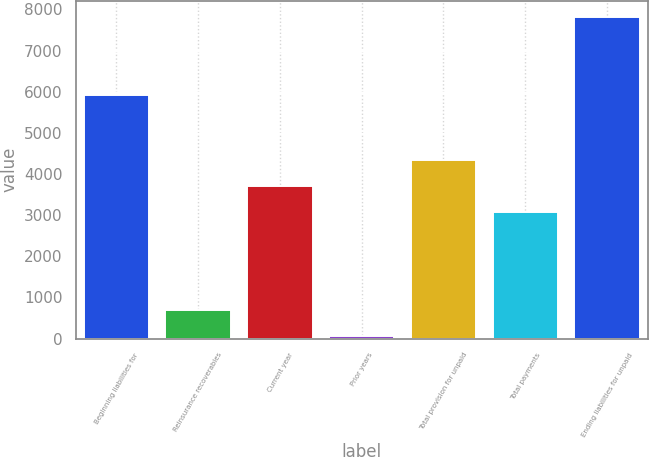Convert chart to OTSL. <chart><loc_0><loc_0><loc_500><loc_500><bar_chart><fcel>Beginning liabilities for<fcel>Reinsurance recoverables<fcel>Current year<fcel>Prior years<fcel>Total provision for unpaid<fcel>Total payments<fcel>Ending liabilities for unpaid<nl><fcel>5918<fcel>701.8<fcel>3700.8<fcel>70<fcel>4332.6<fcel>3069<fcel>7813.4<nl></chart> 